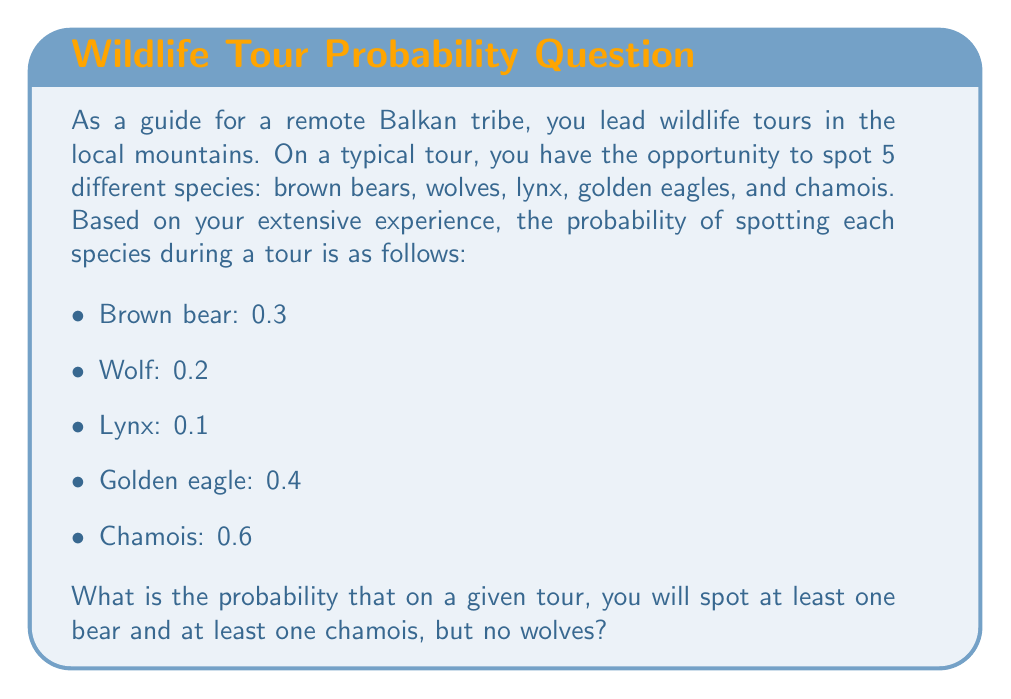Teach me how to tackle this problem. Let's approach this step-by-step using the principles of probability:

1) First, let's define our events:
   $B$: Spotting at least one bear
   $C$: Spotting at least one chamois
   $W$: Spotting no wolves

2) We need to find $P(B \cap C \cap W)$

3) The probability of spotting at least one bear is given, $P(B) = 0.3$

4) The probability of spotting at least one chamois is given, $P(C) = 0.6$

5) The probability of spotting no wolves is the complement of spotting at least one wolf:
   $P(W) = 1 - 0.2 = 0.8$

6) Assuming these events are independent (the spotting of one species doesn't affect the spotting of another), we can multiply these probabilities:

   $$P(B \cap C \cap W) = P(B) \cdot P(C) \cdot P(W)$$

7) Substituting the values:

   $$P(B \cap C \cap W) = 0.3 \cdot 0.6 \cdot 0.8$$

8) Calculating:

   $$P(B \cap C \cap W) = 0.144$$

Therefore, the probability of spotting at least one bear and at least one chamois, but no wolves on a given tour is 0.144 or 14.4%.
Answer: 0.144 